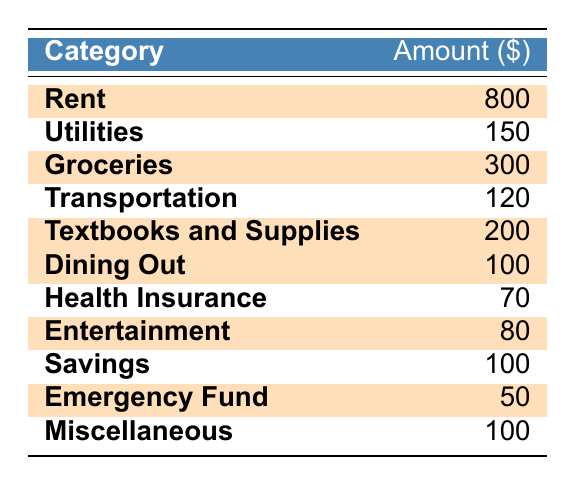What is the amount allocated for Rent? The amount for Rent is directly given in the table as 800.
Answer: 800 How much is allocated to Textbooks and Supplies? The allocation for Textbooks and Supplies is listed in the table as 200.
Answer: 200 What is the total amount allocated to highlighted categories? The amounts for highlighted categories are 800 (Rent), 300 (Groceries), 200 (Textbooks and Supplies), 100 (Dining Out), 80 (Entertainment), and 50 (Emergency Fund). Adding those gives: 800 + 300 + 200 + 100 + 80 + 50 = 1530.
Answer: 1530 Is the amount allocated for Utilities highlighted? Utilities is not highlighted in the table, indicating it is not an important category compared to others.
Answer: No Which category has the lowest amount allocated? The categories are compared: 70 (Health Insurance), 120 (Transportation), 100 (Dining Out), and 50 (Emergency Fund) are all listed. The lowest amount is 50 for the Emergency Fund.
Answer: Emergency Fund What is the difference between the allocations for Groceries and Health Insurance? Groceries is 300, while Health Insurance is 70. The difference is calculated as 300 - 70 = 230.
Answer: 230 What percentage of the total expenses (sum of all categories) is allocated to Savings? First, find the total expenses: 800 + 150 + 300 + 120 + 200 + 100 + 70 + 80 + 100 + 50 + 100 = 2070. Then, Savings is 100. To find the percentage: (100 / 2070) * 100 = 4.83%.
Answer: ~4.83% How many categories are highlighted in the table? Count the highlighted rows: Rent, Groceries, Textbooks and Supplies, Dining Out, Entertainment, and Emergency Fund are highlighted, making a total of 6 categories.
Answer: 6 What is the total amount allocated to non-highlighted categories? The non-highlighted categories include Utilities (150), Transportation (120), Health Insurance (70), Savings (100), and Miscellaneous (100). Adding these gives: 150 + 120 + 70 + 100 + 100 = 540.
Answer: 540 If the amount for Dining Out is doubled, what will the new total for that category be? The current amount for Dining Out is 100. If this is doubled, the total becomes 100 * 2 = 200.
Answer: 200 